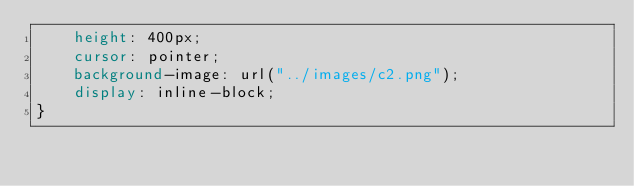Convert code to text. <code><loc_0><loc_0><loc_500><loc_500><_CSS_>    height: 400px;
    cursor: pointer;
    background-image: url("../images/c2.png");
    display: inline-block;
}</code> 